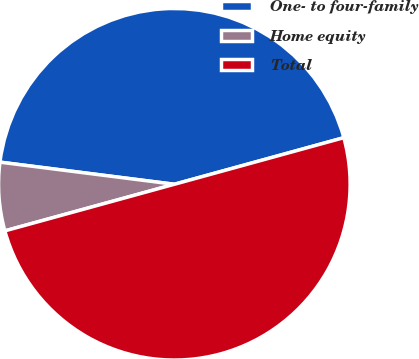Convert chart to OTSL. <chart><loc_0><loc_0><loc_500><loc_500><pie_chart><fcel>One- to four-family<fcel>Home equity<fcel>Total<nl><fcel>43.72%<fcel>6.28%<fcel>50.0%<nl></chart> 